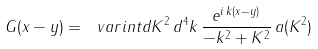<formula> <loc_0><loc_0><loc_500><loc_500>G ( x - y ) = \ v a r i n t d K ^ { 2 } \, d ^ { 4 } k \, \frac { e ^ { i \, k ( x - y ) } } { - k ^ { 2 } + K ^ { 2 } } \, a ( K ^ { 2 } )</formula> 